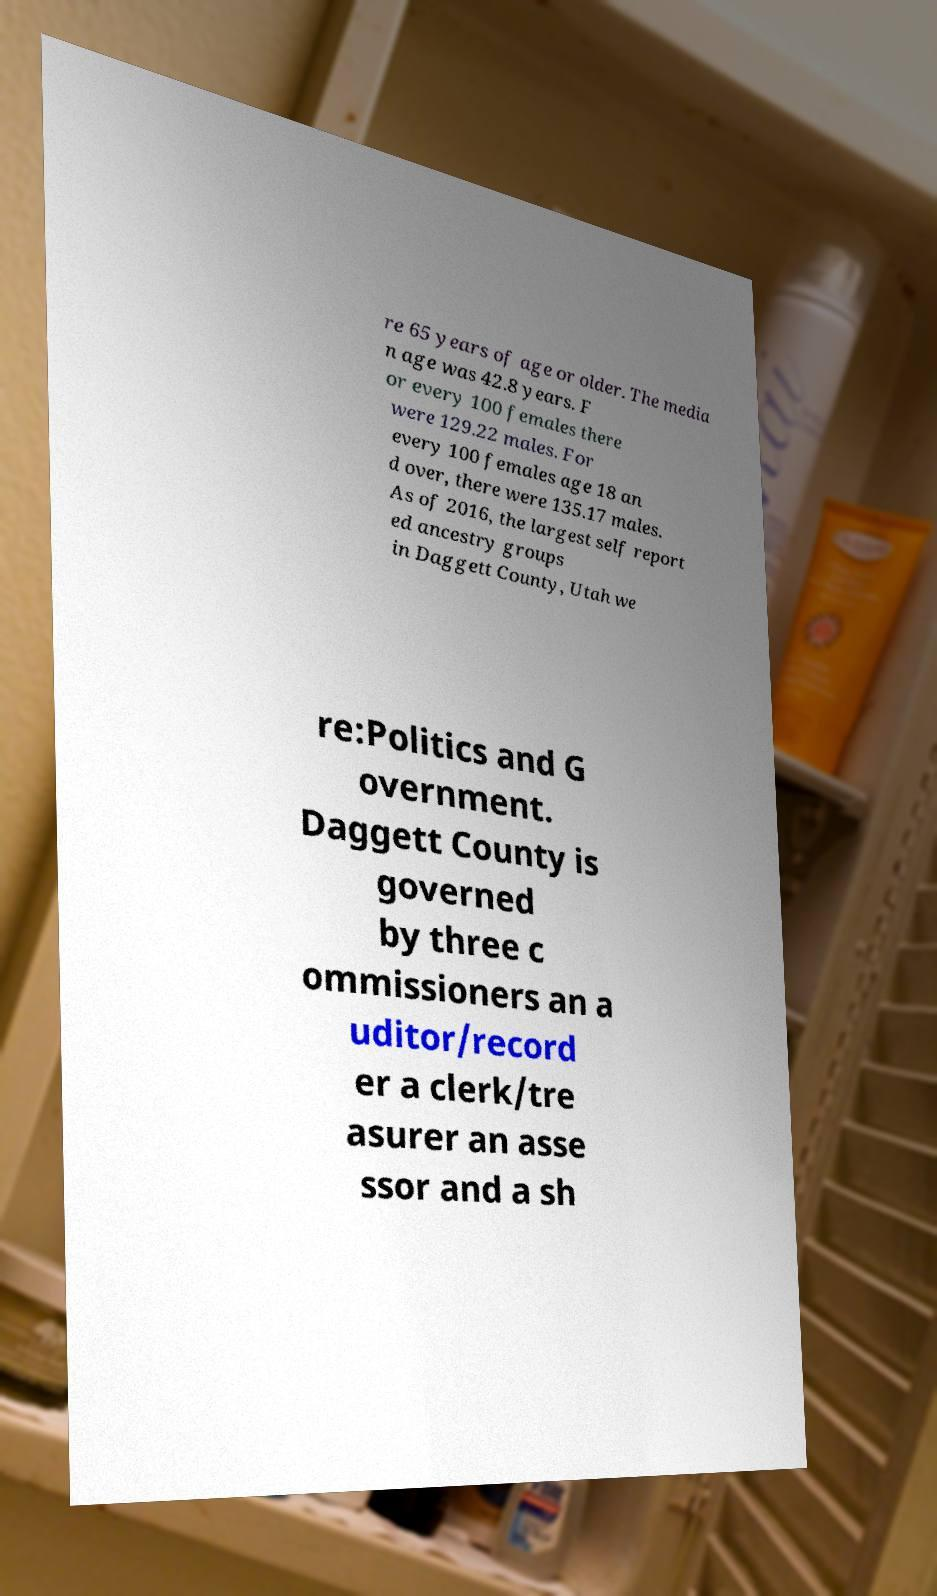Please read and relay the text visible in this image. What does it say? re 65 years of age or older. The media n age was 42.8 years. F or every 100 females there were 129.22 males. For every 100 females age 18 an d over, there were 135.17 males. As of 2016, the largest self report ed ancestry groups in Daggett County, Utah we re:Politics and G overnment. Daggett County is governed by three c ommissioners an a uditor/record er a clerk/tre asurer an asse ssor and a sh 